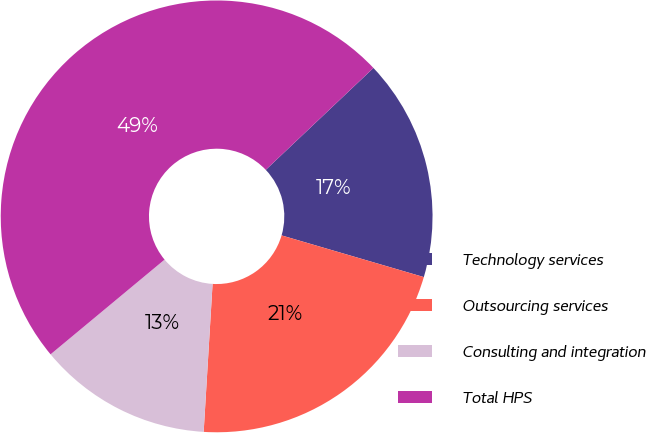Convert chart. <chart><loc_0><loc_0><loc_500><loc_500><pie_chart><fcel>Technology services<fcel>Outsourcing services<fcel>Consulting and integration<fcel>Total HPS<nl><fcel>16.6%<fcel>21.42%<fcel>13.01%<fcel>48.97%<nl></chart> 